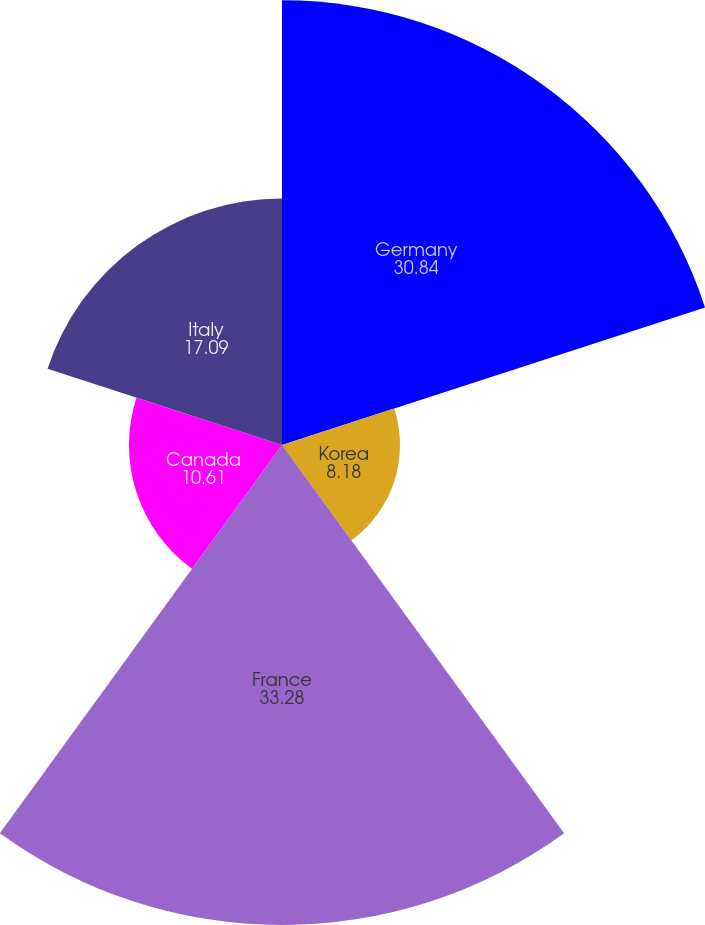<chart> <loc_0><loc_0><loc_500><loc_500><pie_chart><fcel>Germany<fcel>Korea<fcel>France<fcel>Canada<fcel>Italy<nl><fcel>30.84%<fcel>8.18%<fcel>33.28%<fcel>10.61%<fcel>17.09%<nl></chart> 